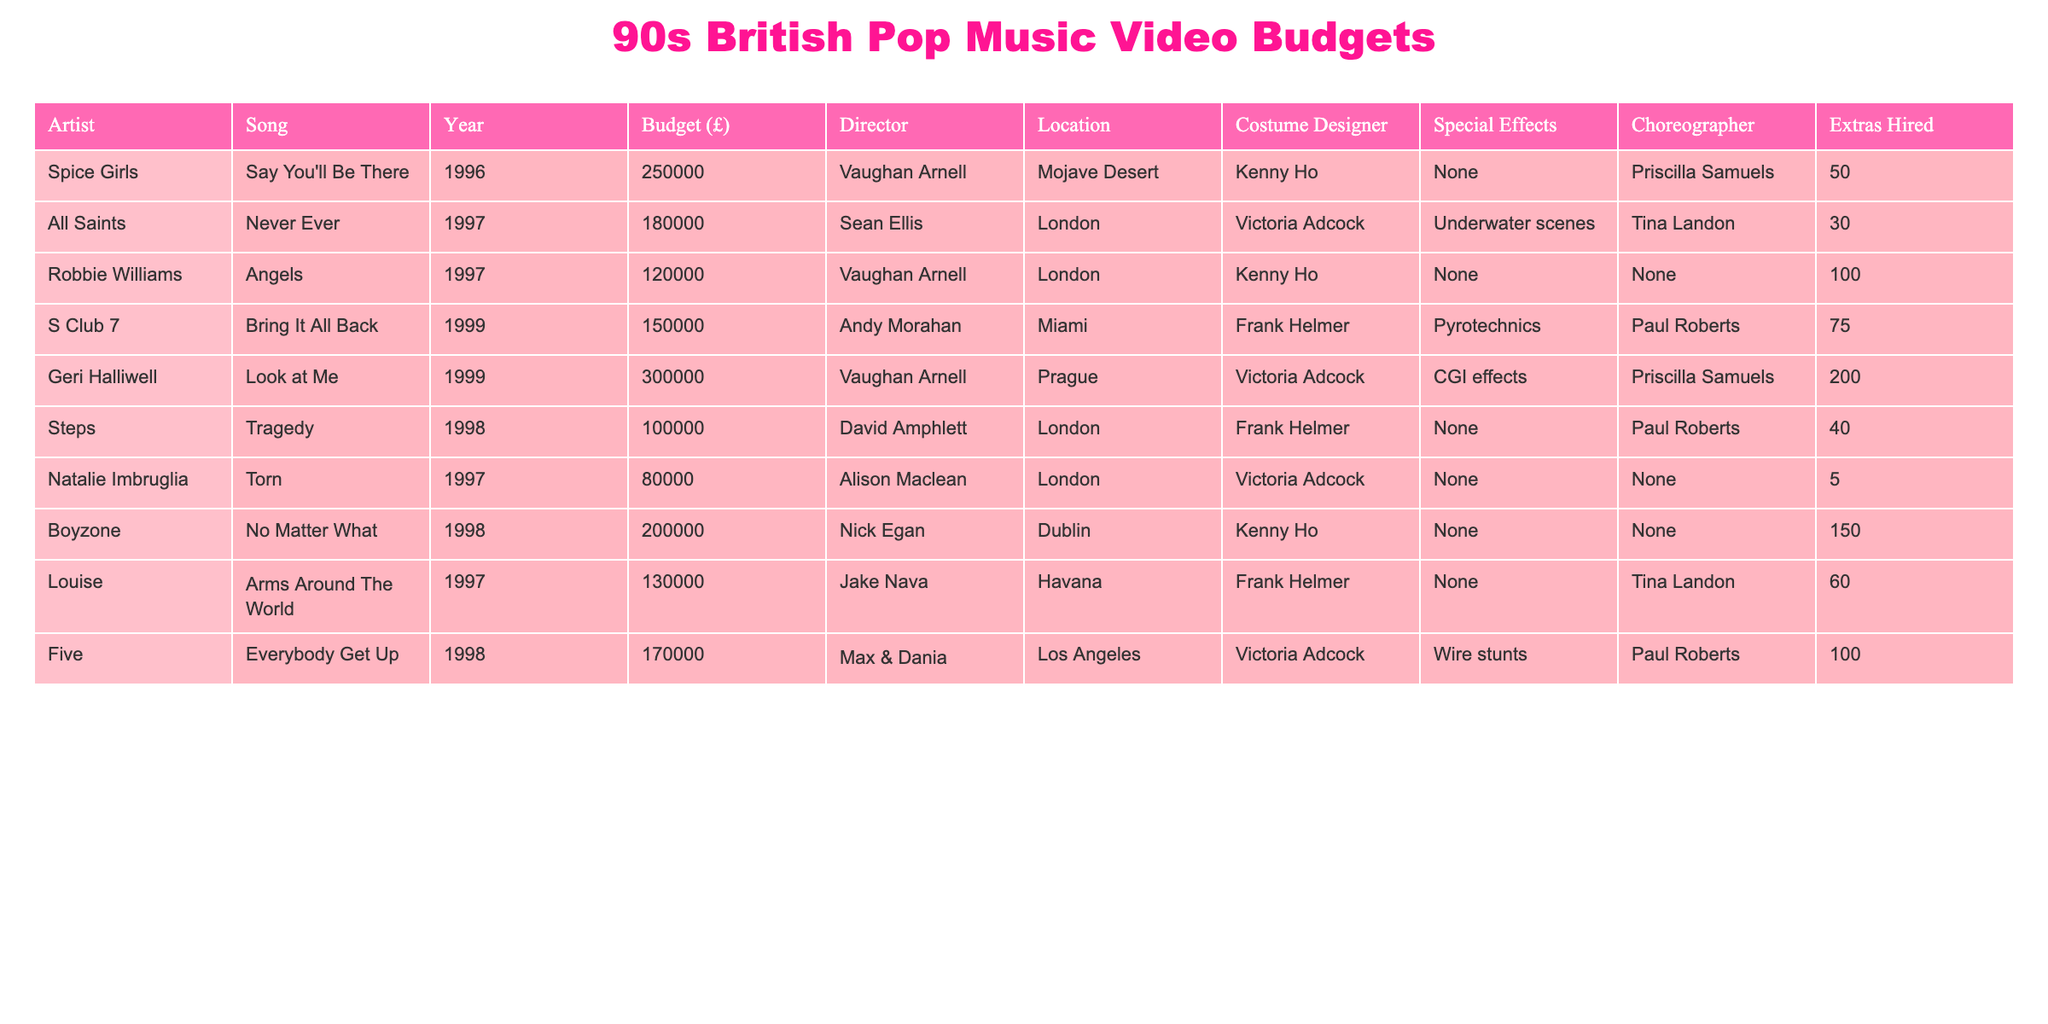What was the budget for the Spice Girls' music video "Say You'll Be There"? The table shows that the budget for "Say You'll Be There" by the Spice Girls is listed as £250,000.
Answer: £250,000 Which music video had the highest budget in this table? By comparing the budgets, "Look at Me" by Geri Halliwell, with a budget of £300,000, has the highest budget in the table.
Answer: "Look at Me" - £300,000 How many extras were hired for the music video "Never Ever"? The table states that for "Never Ever" by All Saints, 30 extras were hired.
Answer: 30 What is the total budget for all the videos listed? To find the total, I sum all the budgets: £250,000 + £180,000 + £120,000 + £150,000 + £300,000 + £100,000 + £80,000 + £200,000 + £130,000 + £170,000 = £1,750,000.
Answer: £1,750,000 Did any music video in this list use special effects? The table indicates that "Look at Me" by Geri Halliwell used CGI effects, therefore at least one video used special effects.
Answer: Yes Which two artists had music videos directed by Vaughan Arnell? By looking at the director column in the table, I find that both "Say You'll Be There" by the Spice Girls and "Look at Me" by Geri Halliwell were directed by Vaughan Arnell.
Answer: Spice Girls, Geri Halliwell What was the budget difference between "Angels" by Robbie Williams and "Tragedy" by Steps? The budget for "Angels" is £120,000 and for "Tragedy" it is £100,000. The difference is £120,000 - £100,000 = £20,000.
Answer: £20,000 Which song had the least budget and who was the artist? "Torn" by Natalie Imbruglia has the least budget of £80,000 according to the table.
Answer: "Torn" by Natalie Imbruglia - £80,000 How many videos were filmed in London according to this table? The table shows that there are four music videos filmed in London: "Never Ever" (All Saints), "Angels" (Robbie Williams), "Tragedy" (Steps), and "Torn" (Natalie Imbruglia).
Answer: 4 Calculate the average budget of the music videos directed by Vaughan Arnell. Vaughan Arnell directed three videos with budgets of £250,000 (Spice Girls), £120,000 (Robbie Williams), and £300,000 (Geri Halliwell). The total is £670,000, and the average is £670,000 / 3 = £223,333.33.
Answer: £223,333.33 